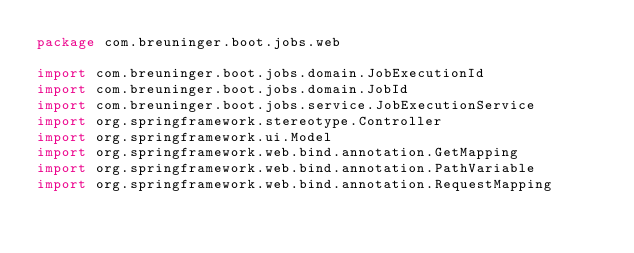Convert code to text. <code><loc_0><loc_0><loc_500><loc_500><_Kotlin_>package com.breuninger.boot.jobs.web

import com.breuninger.boot.jobs.domain.JobExecutionId
import com.breuninger.boot.jobs.domain.JobId
import com.breuninger.boot.jobs.service.JobExecutionService
import org.springframework.stereotype.Controller
import org.springframework.ui.Model
import org.springframework.web.bind.annotation.GetMapping
import org.springframework.web.bind.annotation.PathVariable
import org.springframework.web.bind.annotation.RequestMapping</code> 